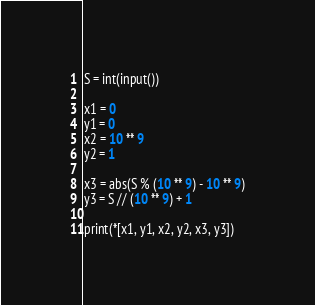<code> <loc_0><loc_0><loc_500><loc_500><_Python_>S = int(input())

x1 = 0
y1 = 0
x2 = 10 ** 9
y2 = 1

x3 = abs(S % (10 ** 9) - 10 ** 9)
y3 = S // (10 ** 9) + 1

print(*[x1, y1, x2, y2, x3, y3])</code> 